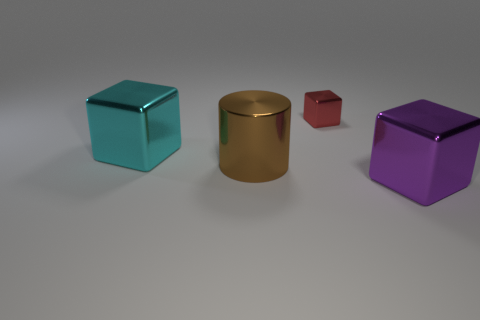Can you tell me what colors the objects in the image are? Sure, there are four objects, each with a distinct color: teal, gold, red, and purple. 